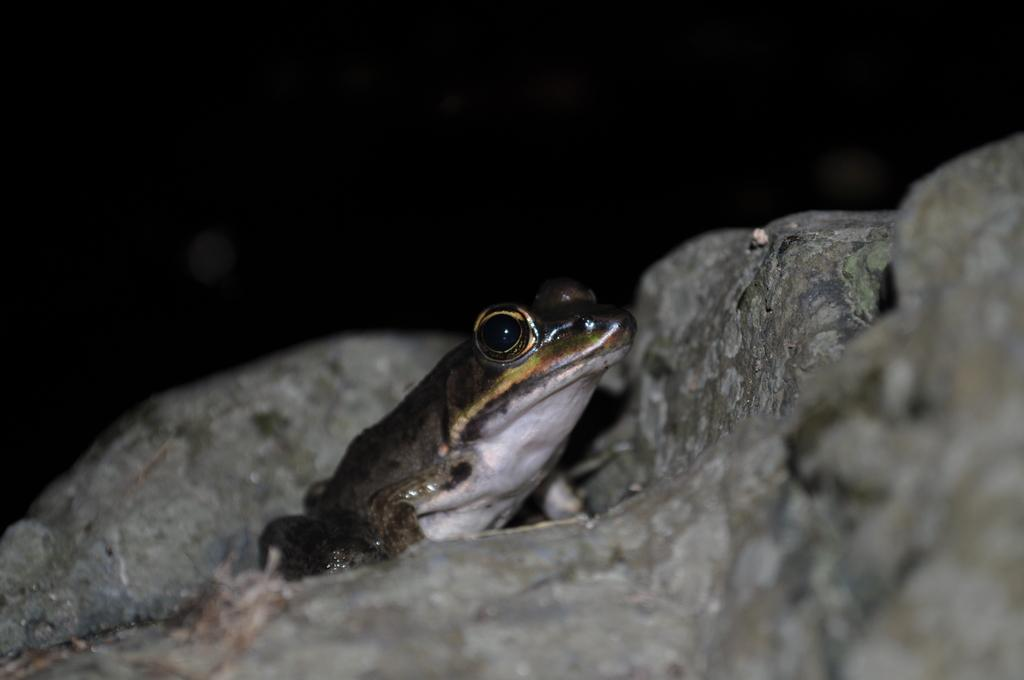What is the main subject of the picture? The main subject of the picture is a frog. Where is the frog located in the picture? The frog is on a rock surface. What is the color of the frog? The frog is green in color. What other elements can be seen in the picture? There are rocks visible in the picture. Can you describe the creature under the frog? There is a creature with white color and an eye under the frog. What type of flavor can be tasted from the frog in the image? The image does not depict any flavor or taste, as it is a photograph of a frog on a rock surface. 